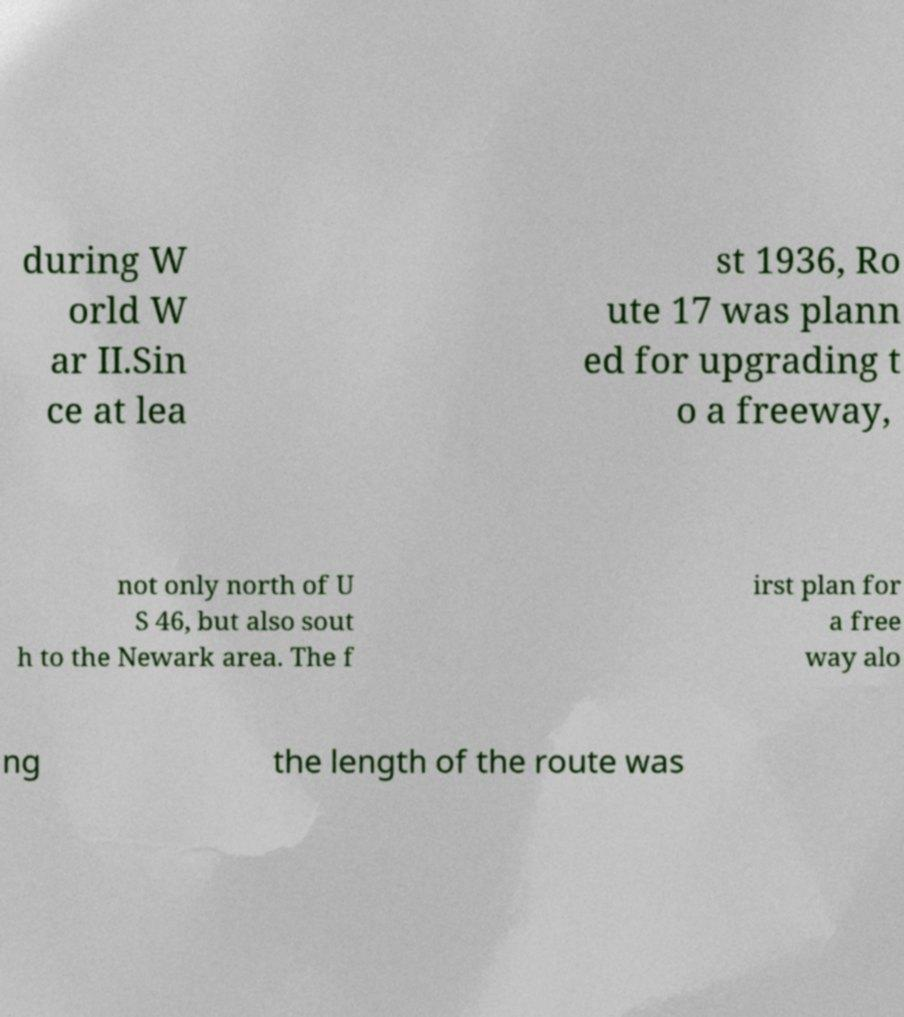Could you extract and type out the text from this image? during W orld W ar II.Sin ce at lea st 1936, Ro ute 17 was plann ed for upgrading t o a freeway, not only north of U S 46, but also sout h to the Newark area. The f irst plan for a free way alo ng the length of the route was 